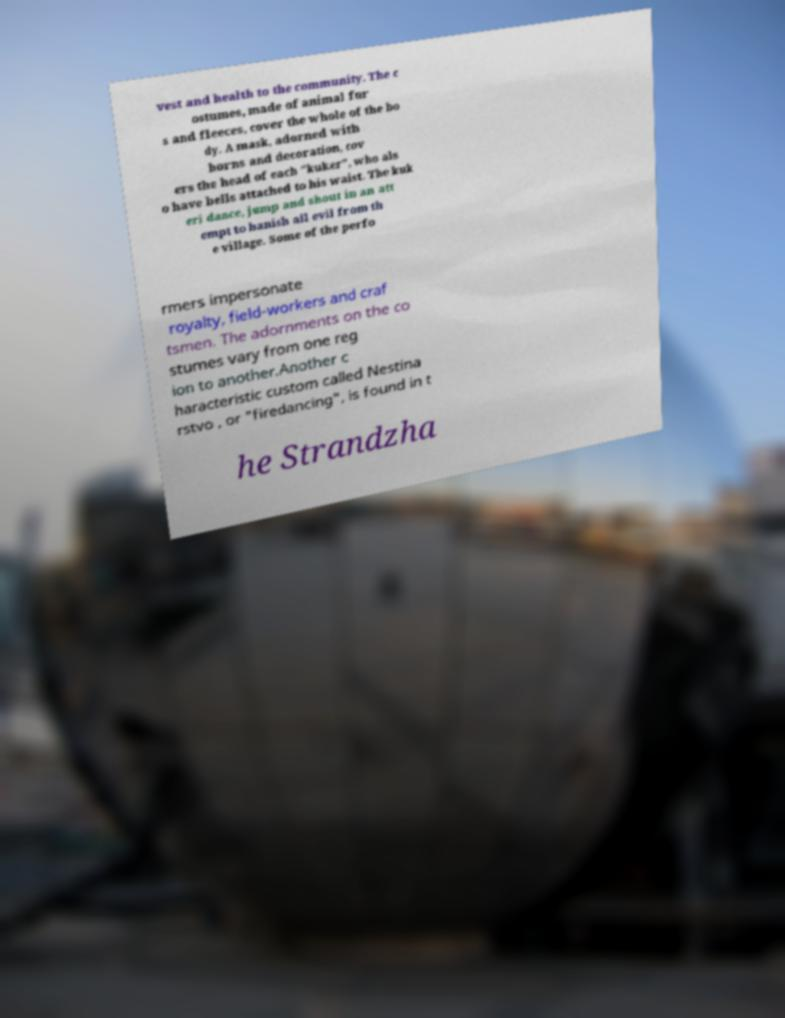There's text embedded in this image that I need extracted. Can you transcribe it verbatim? vest and health to the community. The c ostumes, made of animal fur s and fleeces, cover the whole of the bo dy. A mask, adorned with horns and decoration, cov ers the head of each "kuker", who als o have bells attached to his waist. The kuk eri dance, jump and shout in an att empt to banish all evil from th e village. Some of the perfo rmers impersonate royalty, field-workers and craf tsmen. The adornments on the co stumes vary from one reg ion to another.Another c haracteristic custom called Nestina rstvo , or "firedancing", is found in t he Strandzha 